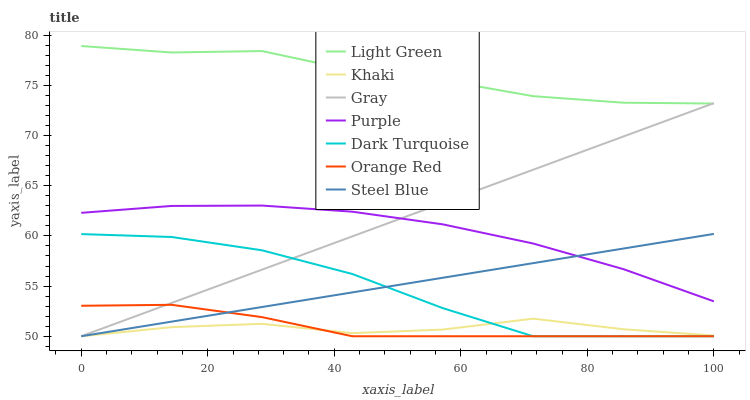Does Khaki have the minimum area under the curve?
Answer yes or no. Yes. Does Light Green have the maximum area under the curve?
Answer yes or no. Yes. Does Purple have the minimum area under the curve?
Answer yes or no. No. Does Purple have the maximum area under the curve?
Answer yes or no. No. Is Steel Blue the smoothest?
Answer yes or no. Yes. Is Dark Turquoise the roughest?
Answer yes or no. Yes. Is Khaki the smoothest?
Answer yes or no. No. Is Khaki the roughest?
Answer yes or no. No. Does Gray have the lowest value?
Answer yes or no. Yes. Does Purple have the lowest value?
Answer yes or no. No. Does Light Green have the highest value?
Answer yes or no. Yes. Does Purple have the highest value?
Answer yes or no. No. Is Orange Red less than Purple?
Answer yes or no. Yes. Is Purple greater than Orange Red?
Answer yes or no. Yes. Does Gray intersect Khaki?
Answer yes or no. Yes. Is Gray less than Khaki?
Answer yes or no. No. Is Gray greater than Khaki?
Answer yes or no. No. Does Orange Red intersect Purple?
Answer yes or no. No. 